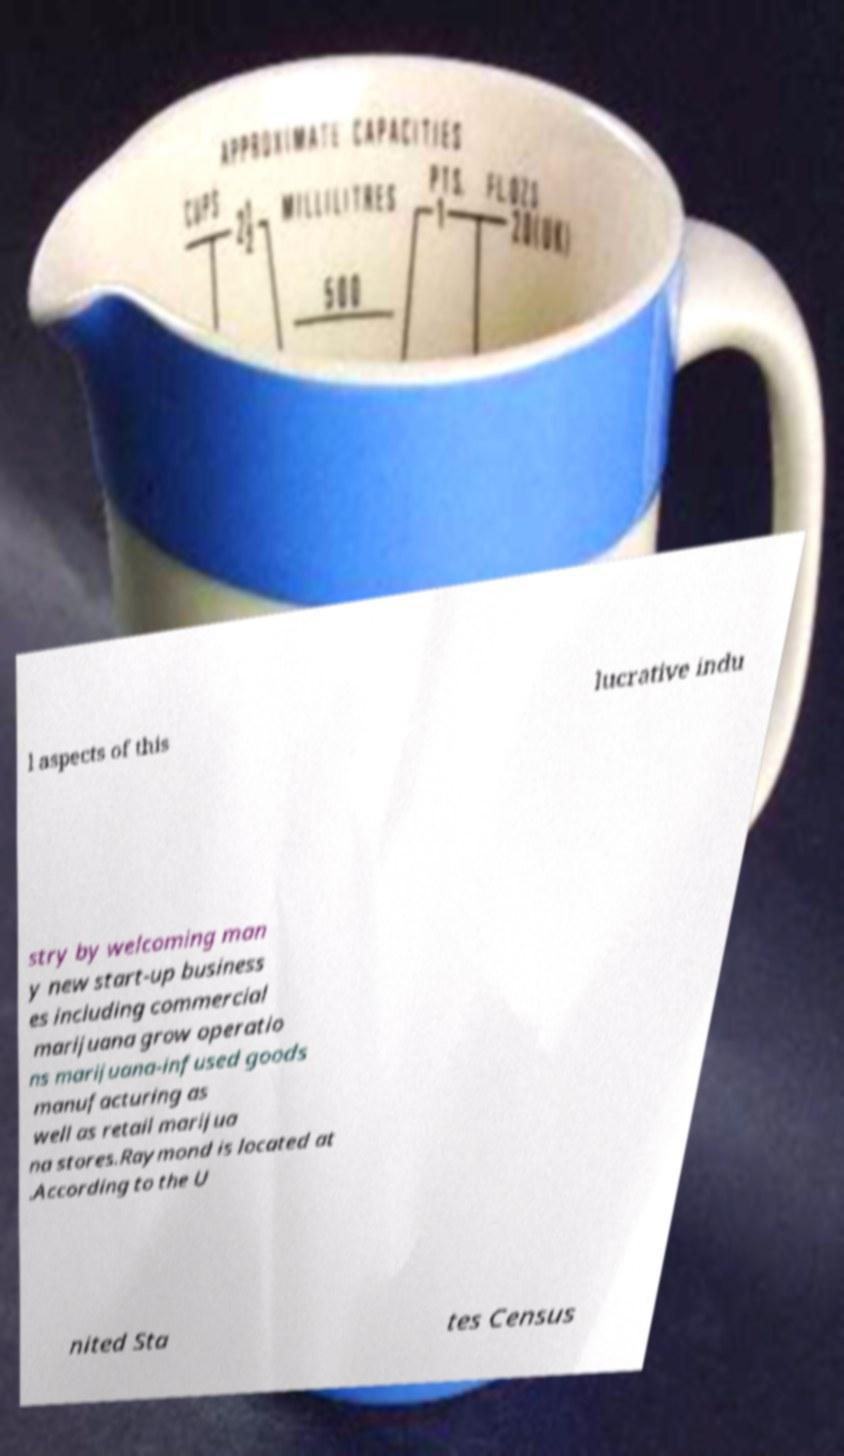Could you assist in decoding the text presented in this image and type it out clearly? l aspects of this lucrative indu stry by welcoming man y new start-up business es including commercial marijuana grow operatio ns marijuana-infused goods manufacturing as well as retail marijua na stores.Raymond is located at .According to the U nited Sta tes Census 